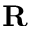Convert formula to latex. <formula><loc_0><loc_0><loc_500><loc_500>R</formula> 